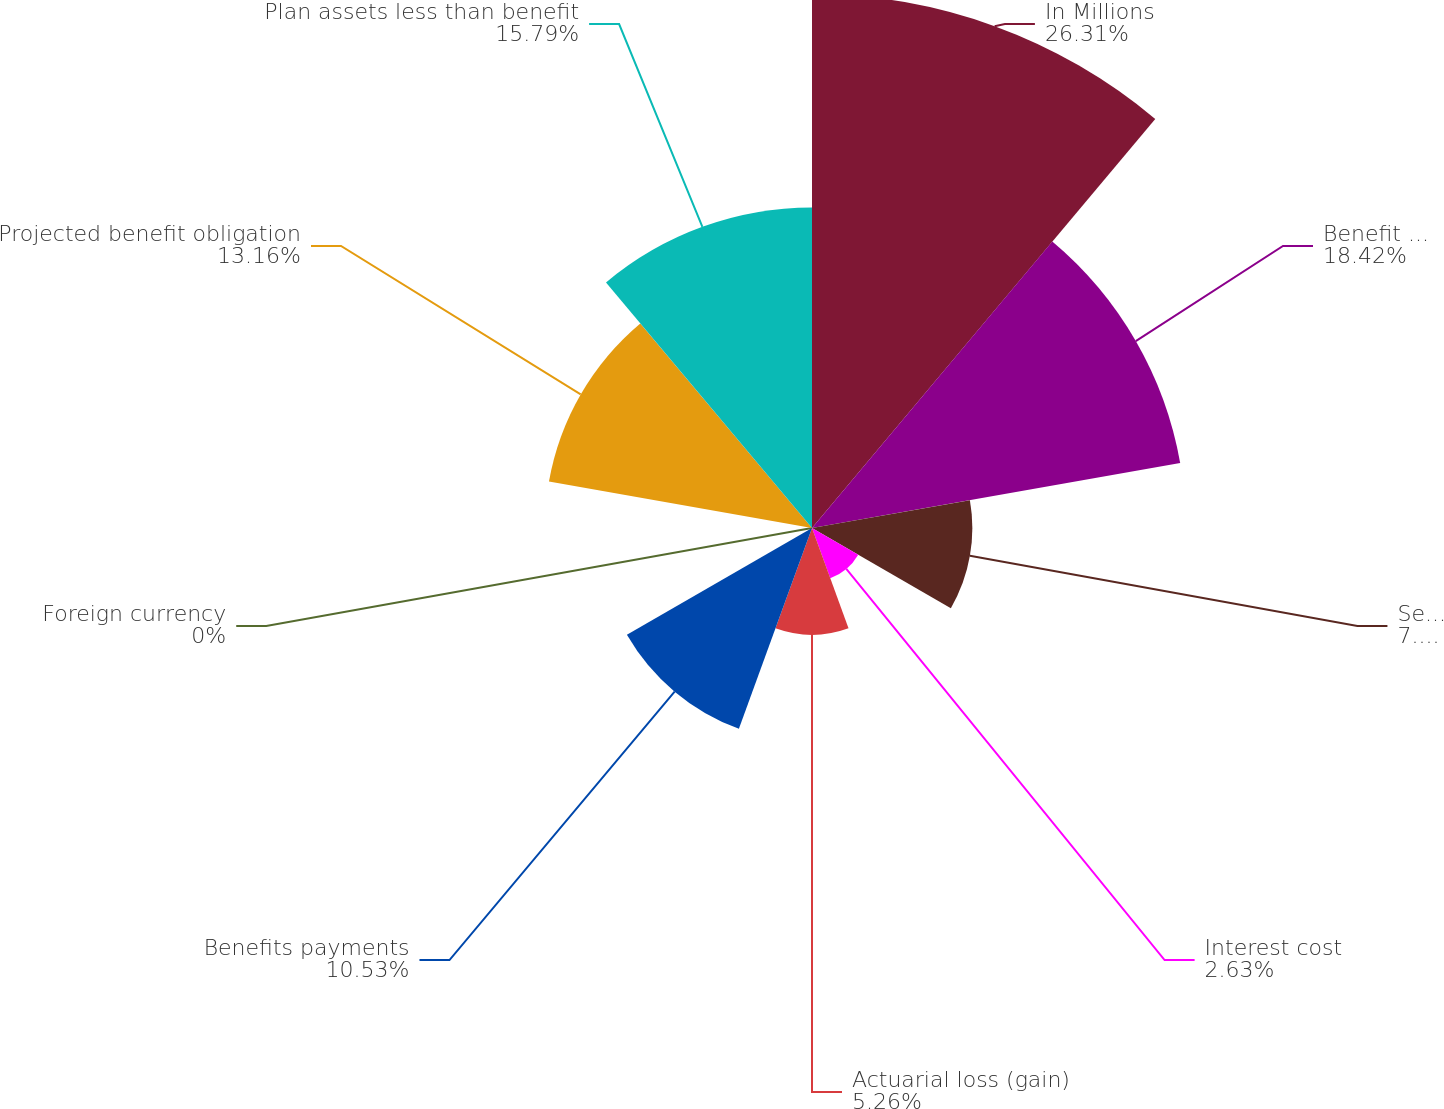Convert chart. <chart><loc_0><loc_0><loc_500><loc_500><pie_chart><fcel>In Millions<fcel>Benefit obligation at<fcel>Service cost<fcel>Interest cost<fcel>Actuarial loss (gain)<fcel>Benefits payments<fcel>Foreign currency<fcel>Projected benefit obligation<fcel>Plan assets less than benefit<nl><fcel>26.31%<fcel>18.42%<fcel>7.9%<fcel>2.63%<fcel>5.26%<fcel>10.53%<fcel>0.0%<fcel>13.16%<fcel>15.79%<nl></chart> 